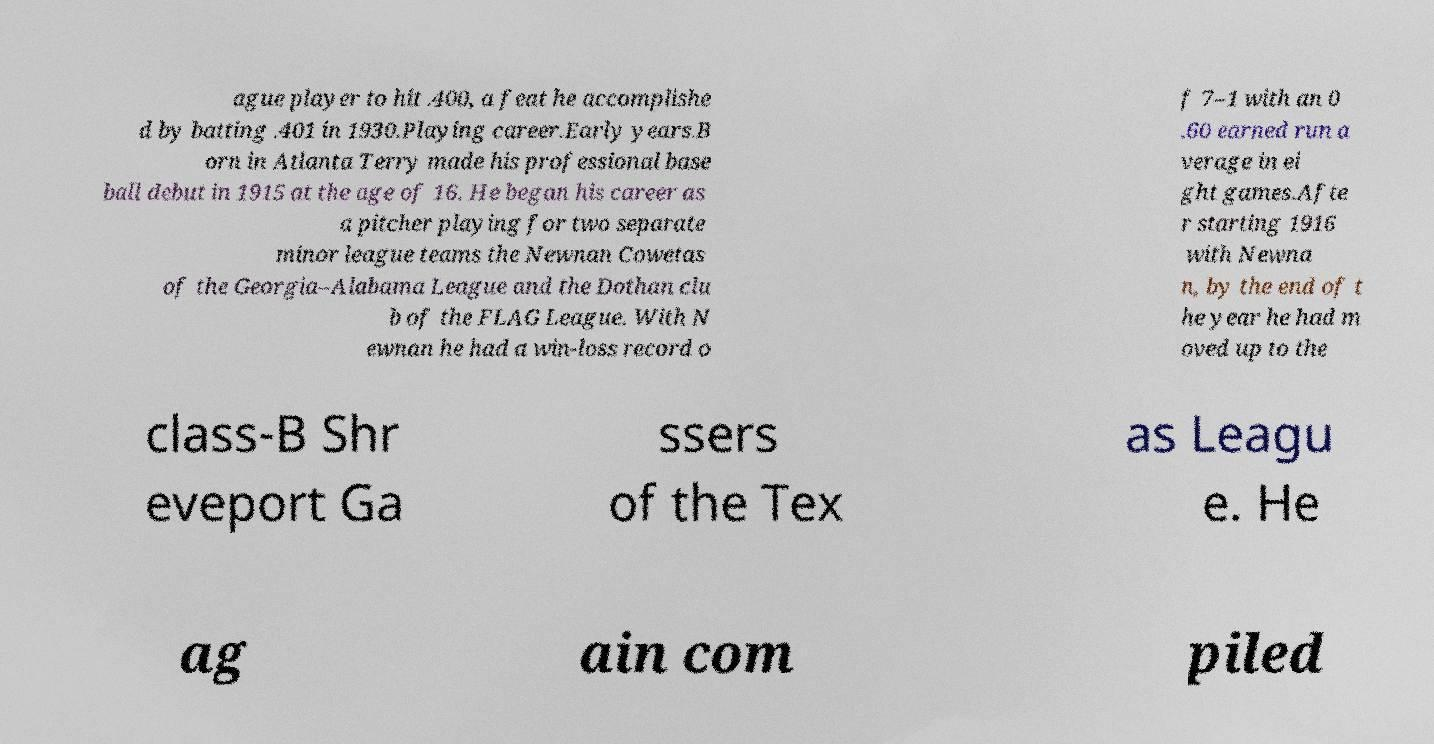I need the written content from this picture converted into text. Can you do that? ague player to hit .400, a feat he accomplishe d by batting .401 in 1930.Playing career.Early years.B orn in Atlanta Terry made his professional base ball debut in 1915 at the age of 16. He began his career as a pitcher playing for two separate minor league teams the Newnan Cowetas of the Georgia–Alabama League and the Dothan clu b of the FLAG League. With N ewnan he had a win-loss record o f 7–1 with an 0 .60 earned run a verage in ei ght games.Afte r starting 1916 with Newna n, by the end of t he year he had m oved up to the class-B Shr eveport Ga ssers of the Tex as Leagu e. He ag ain com piled 